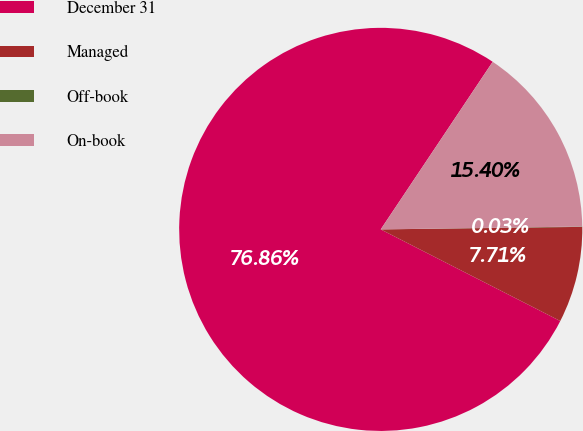Convert chart. <chart><loc_0><loc_0><loc_500><loc_500><pie_chart><fcel>December 31<fcel>Managed<fcel>Off-book<fcel>On-book<nl><fcel>76.87%<fcel>7.71%<fcel>0.03%<fcel>15.4%<nl></chart> 